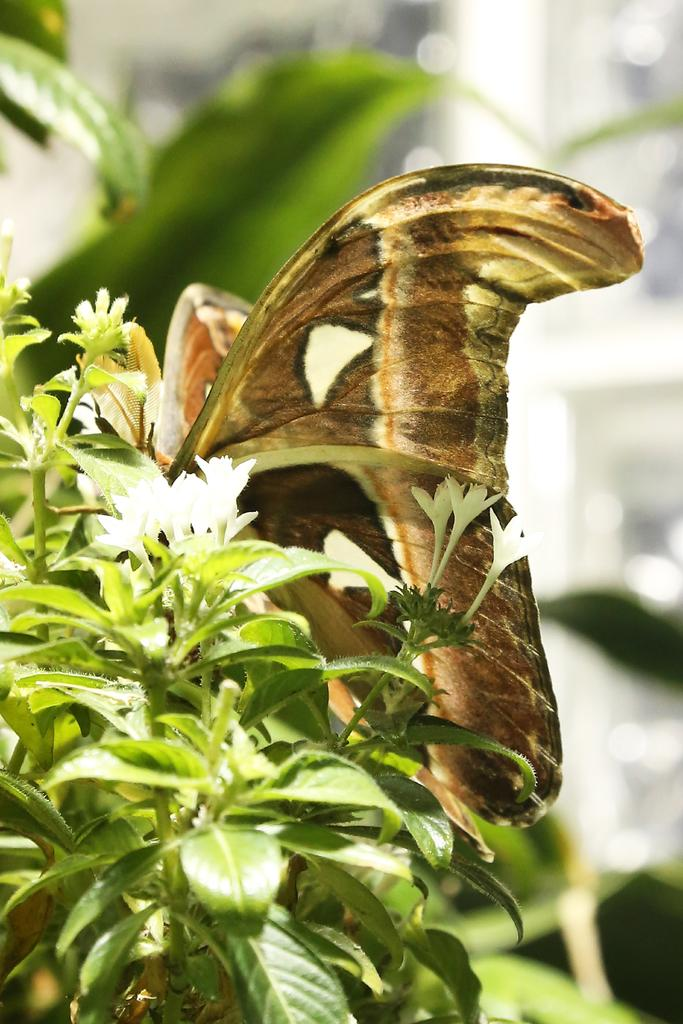What is the main subject of the image? The main subject of the image is a butterfly on a plant. What type of flowers are near the butterfly? There are white flowers beside the butterfly in the image. How does the butterfly feel about the credit score of the person who took the picture? There is no information about credit scores or the person who took the picture in the image, so it is impossible to determine how the butterfly might feel about it. 